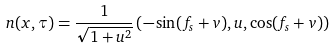Convert formula to latex. <formula><loc_0><loc_0><loc_500><loc_500>{ n } ( x , \tau ) = \frac { 1 } { \sqrt { 1 + u ^ { 2 } } } \left ( - \sin ( f _ { s } + v ) , u , \cos ( f _ { s } + v ) \right )</formula> 